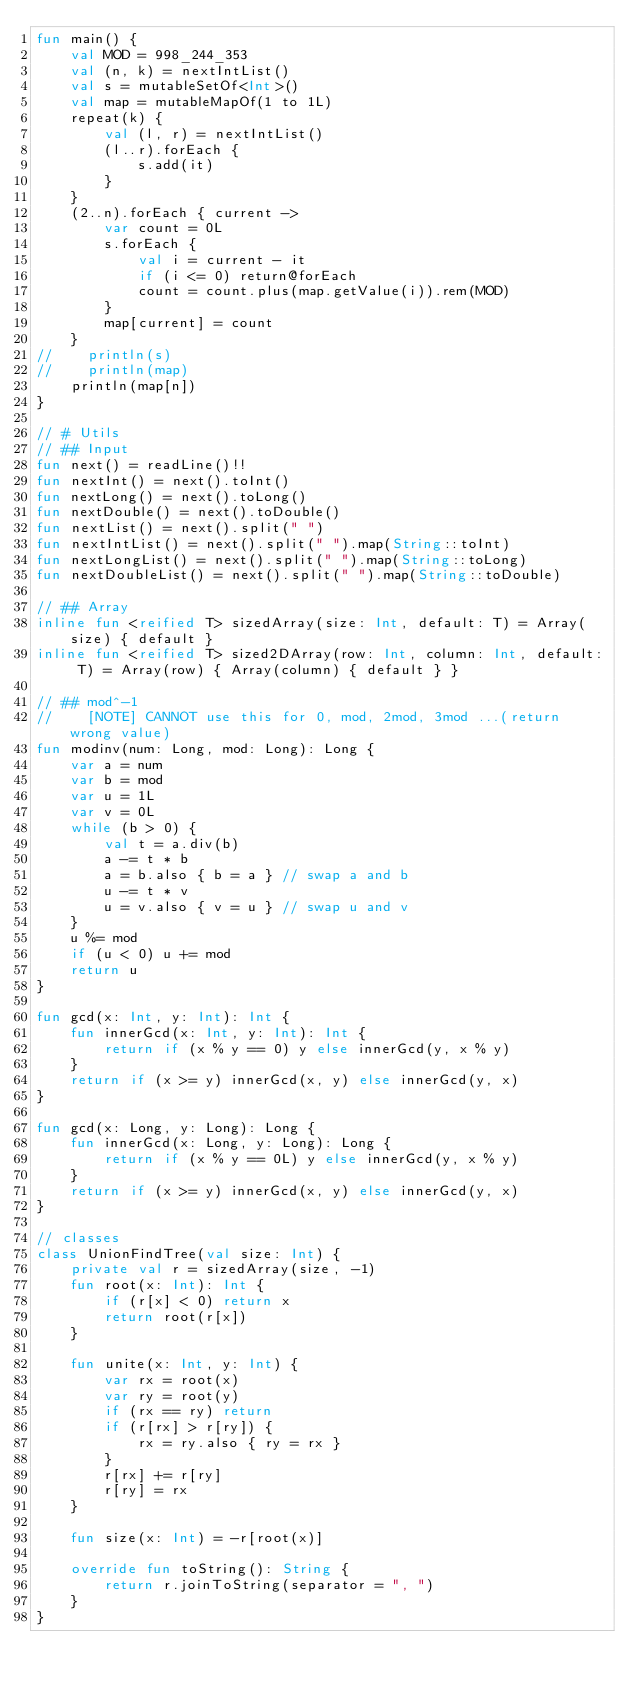Convert code to text. <code><loc_0><loc_0><loc_500><loc_500><_Kotlin_>fun main() {
    val MOD = 998_244_353
    val (n, k) = nextIntList()
    val s = mutableSetOf<Int>()
    val map = mutableMapOf(1 to 1L)
    repeat(k) {
        val (l, r) = nextIntList()
        (l..r).forEach {
            s.add(it)
        }
    }
    (2..n).forEach { current ->
        var count = 0L
        s.forEach {
            val i = current - it
            if (i <= 0) return@forEach
            count = count.plus(map.getValue(i)).rem(MOD)
        }
        map[current] = count
    }
//    println(s)
//    println(map)
    println(map[n])
}

// # Utils
// ## Input
fun next() = readLine()!!
fun nextInt() = next().toInt()
fun nextLong() = next().toLong()
fun nextDouble() = next().toDouble()
fun nextList() = next().split(" ")
fun nextIntList() = next().split(" ").map(String::toInt)
fun nextLongList() = next().split(" ").map(String::toLong)
fun nextDoubleList() = next().split(" ").map(String::toDouble)

// ## Array
inline fun <reified T> sizedArray(size: Int, default: T) = Array(size) { default }
inline fun <reified T> sized2DArray(row: Int, column: Int, default: T) = Array(row) { Array(column) { default } }

// ## mod^-1
//    [NOTE] CANNOT use this for 0, mod, 2mod, 3mod ...(return wrong value)
fun modinv(num: Long, mod: Long): Long {
    var a = num
    var b = mod
    var u = 1L
    var v = 0L
    while (b > 0) {
        val t = a.div(b)
        a -= t * b
        a = b.also { b = a } // swap a and b
        u -= t * v
        u = v.also { v = u } // swap u and v
    }
    u %= mod
    if (u < 0) u += mod
    return u
}

fun gcd(x: Int, y: Int): Int {
    fun innerGcd(x: Int, y: Int): Int {
        return if (x % y == 0) y else innerGcd(y, x % y)
    }
    return if (x >= y) innerGcd(x, y) else innerGcd(y, x)
}

fun gcd(x: Long, y: Long): Long {
    fun innerGcd(x: Long, y: Long): Long {
        return if (x % y == 0L) y else innerGcd(y, x % y)
    }
    return if (x >= y) innerGcd(x, y) else innerGcd(y, x)
}

// classes
class UnionFindTree(val size: Int) {
    private val r = sizedArray(size, -1)
    fun root(x: Int): Int {
        if (r[x] < 0) return x
        return root(r[x])
    }

    fun unite(x: Int, y: Int) {
        var rx = root(x)
        var ry = root(y)
        if (rx == ry) return
        if (r[rx] > r[ry]) {
            rx = ry.also { ry = rx }
        }
        r[rx] += r[ry]
        r[ry] = rx
    }

    fun size(x: Int) = -r[root(x)]

    override fun toString(): String {
        return r.joinToString(separator = ", ")
    }
}</code> 